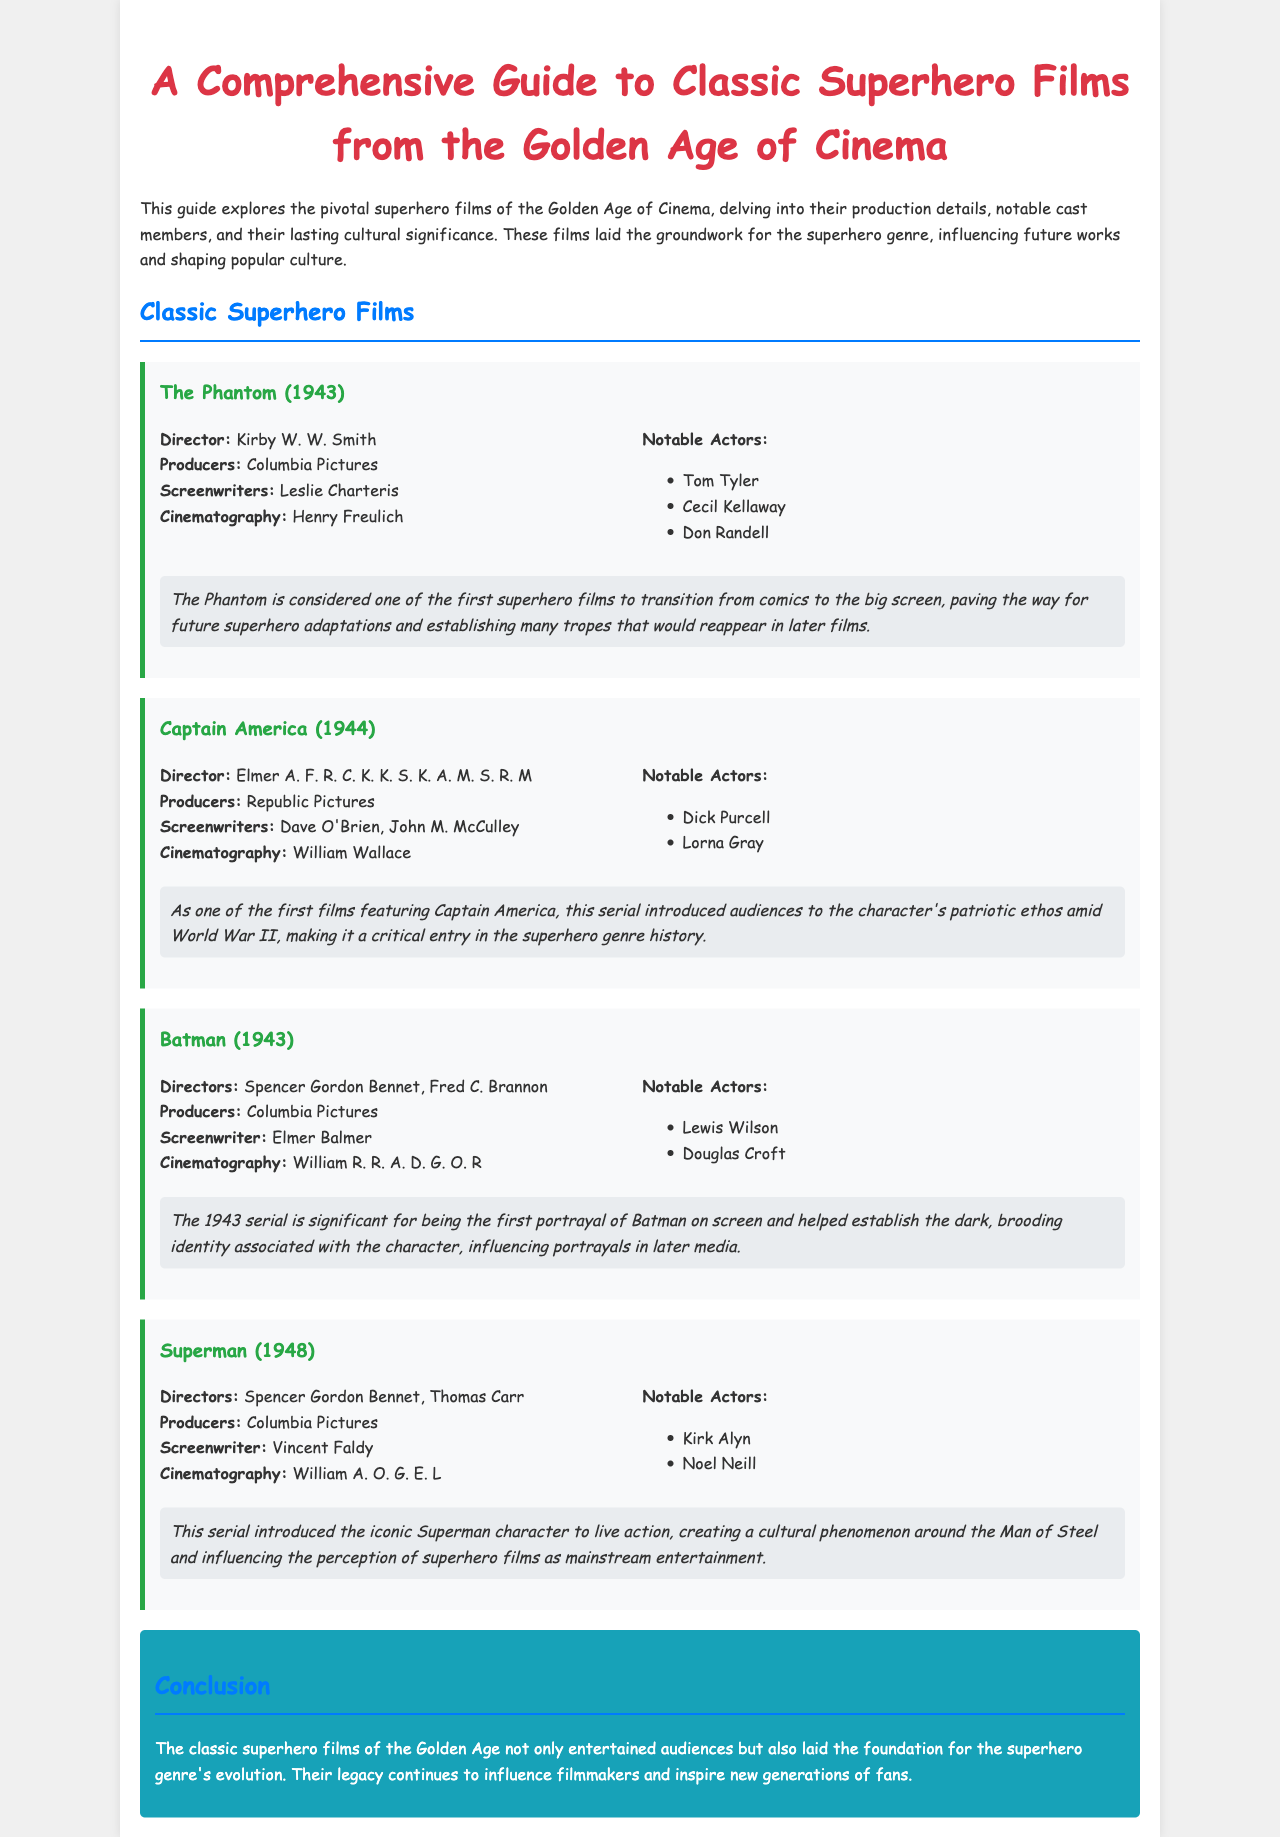What is the title of the guide? The title of the guide is explicitly stated at the beginning, "A Comprehensive Guide to Classic Superhero Films from the Golden Age of Cinema."
Answer: A Comprehensive Guide to Classic Superhero Films from the Golden Age of Cinema Who directed "The Phantom"? The guide lists the director of "The Phantom" as Kirby W. W. Smith.
Answer: Kirby W. W. Smith Which year was "Captain America" released? The document specifies the release year of "Captain America" as 1944.
Answer: 1944 Name one notable actor from "Batman." The guide mentions Lewis Wilson as one of the notable actors in "Batman."
Answer: Lewis Wilson What production company created "Superman"? According to the document, Superman was produced by Columbia Pictures.
Answer: Columbia Pictures What cultural impact did "The Phantom" have? The document states that "The Phantom" established many tropes for future superhero adaptations.
Answer: Established many tropes How many directors worked on "Superman"? The information provided indicates that there were two directors for "Superman."
Answer: Two What is the main theme of the conclusion? The conclusion summarizes the impact of classic superhero films on the genre's evolution.
Answer: Impact on genre's evolution Which film is considered the first portrayal of Batman on screen? The document states that the 1943 serial is significant for being the first portrayal of Batman.
Answer: 1943 serial 